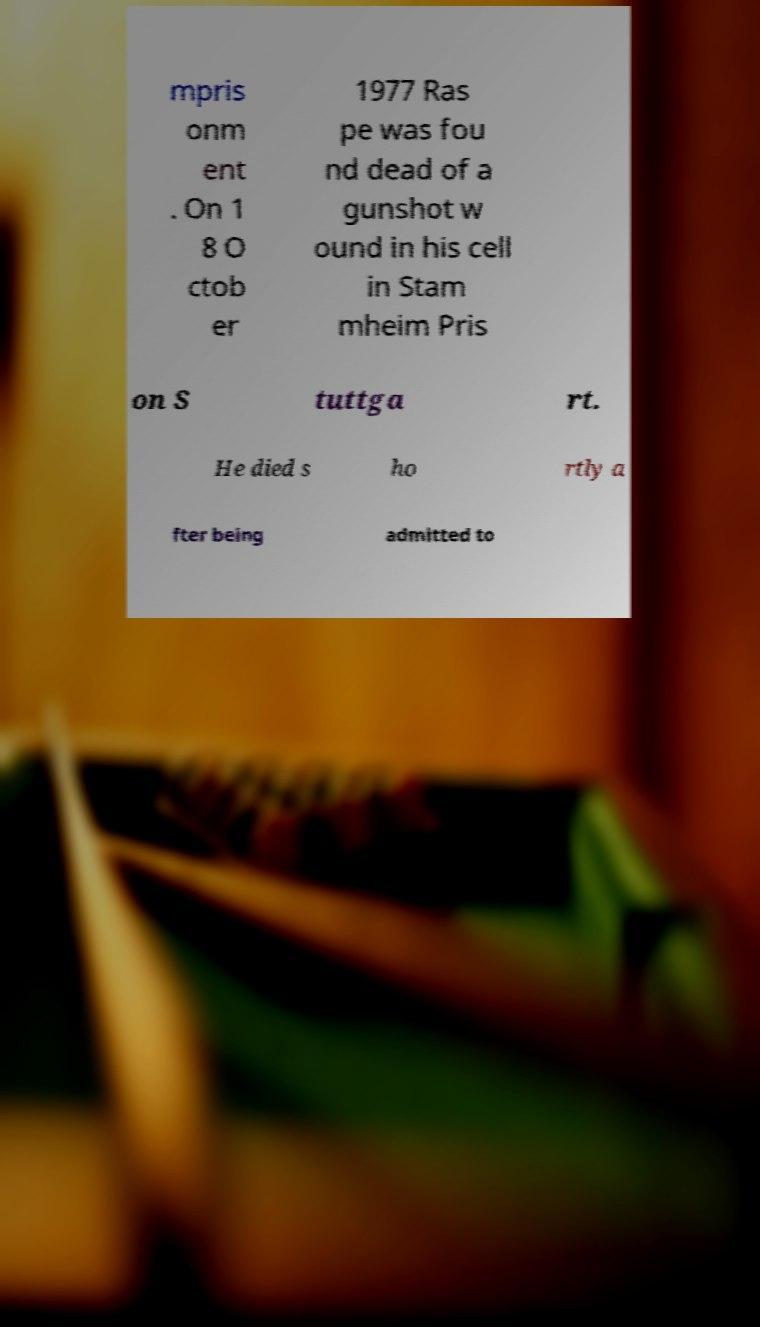I need the written content from this picture converted into text. Can you do that? mpris onm ent . On 1 8 O ctob er 1977 Ras pe was fou nd dead of a gunshot w ound in his cell in Stam mheim Pris on S tuttga rt. He died s ho rtly a fter being admitted to 